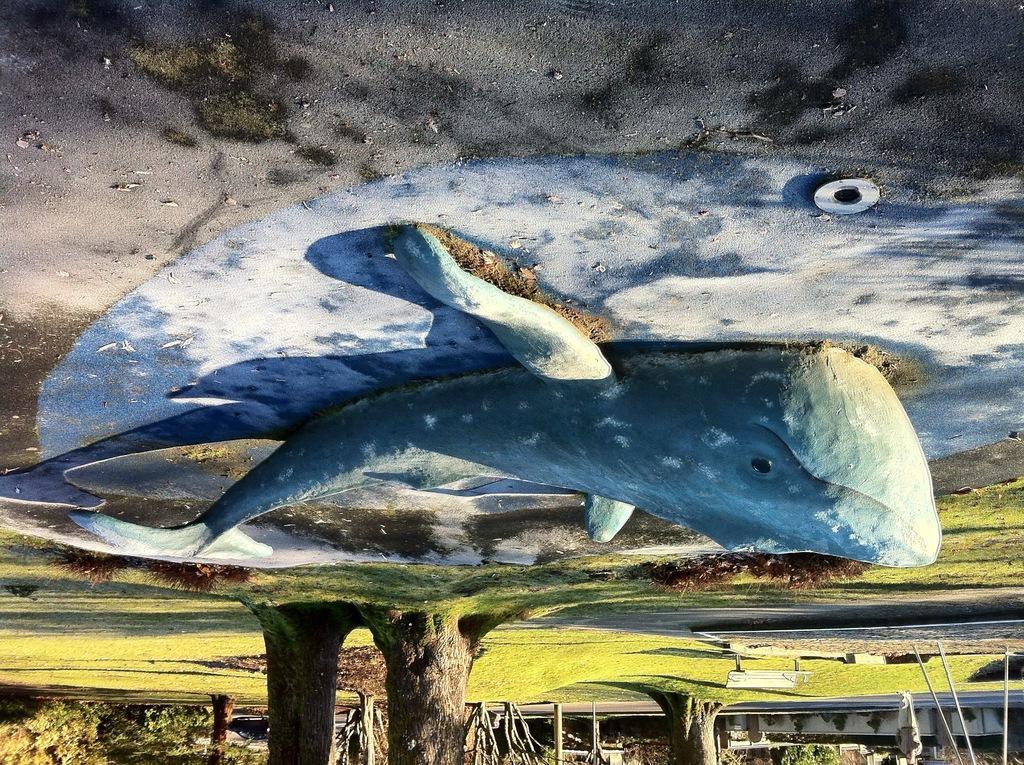In one or two sentences, can you explain what this image depicts? In the picture there is a statue of a fish present on the floor, beside there are trees, there is grass. 